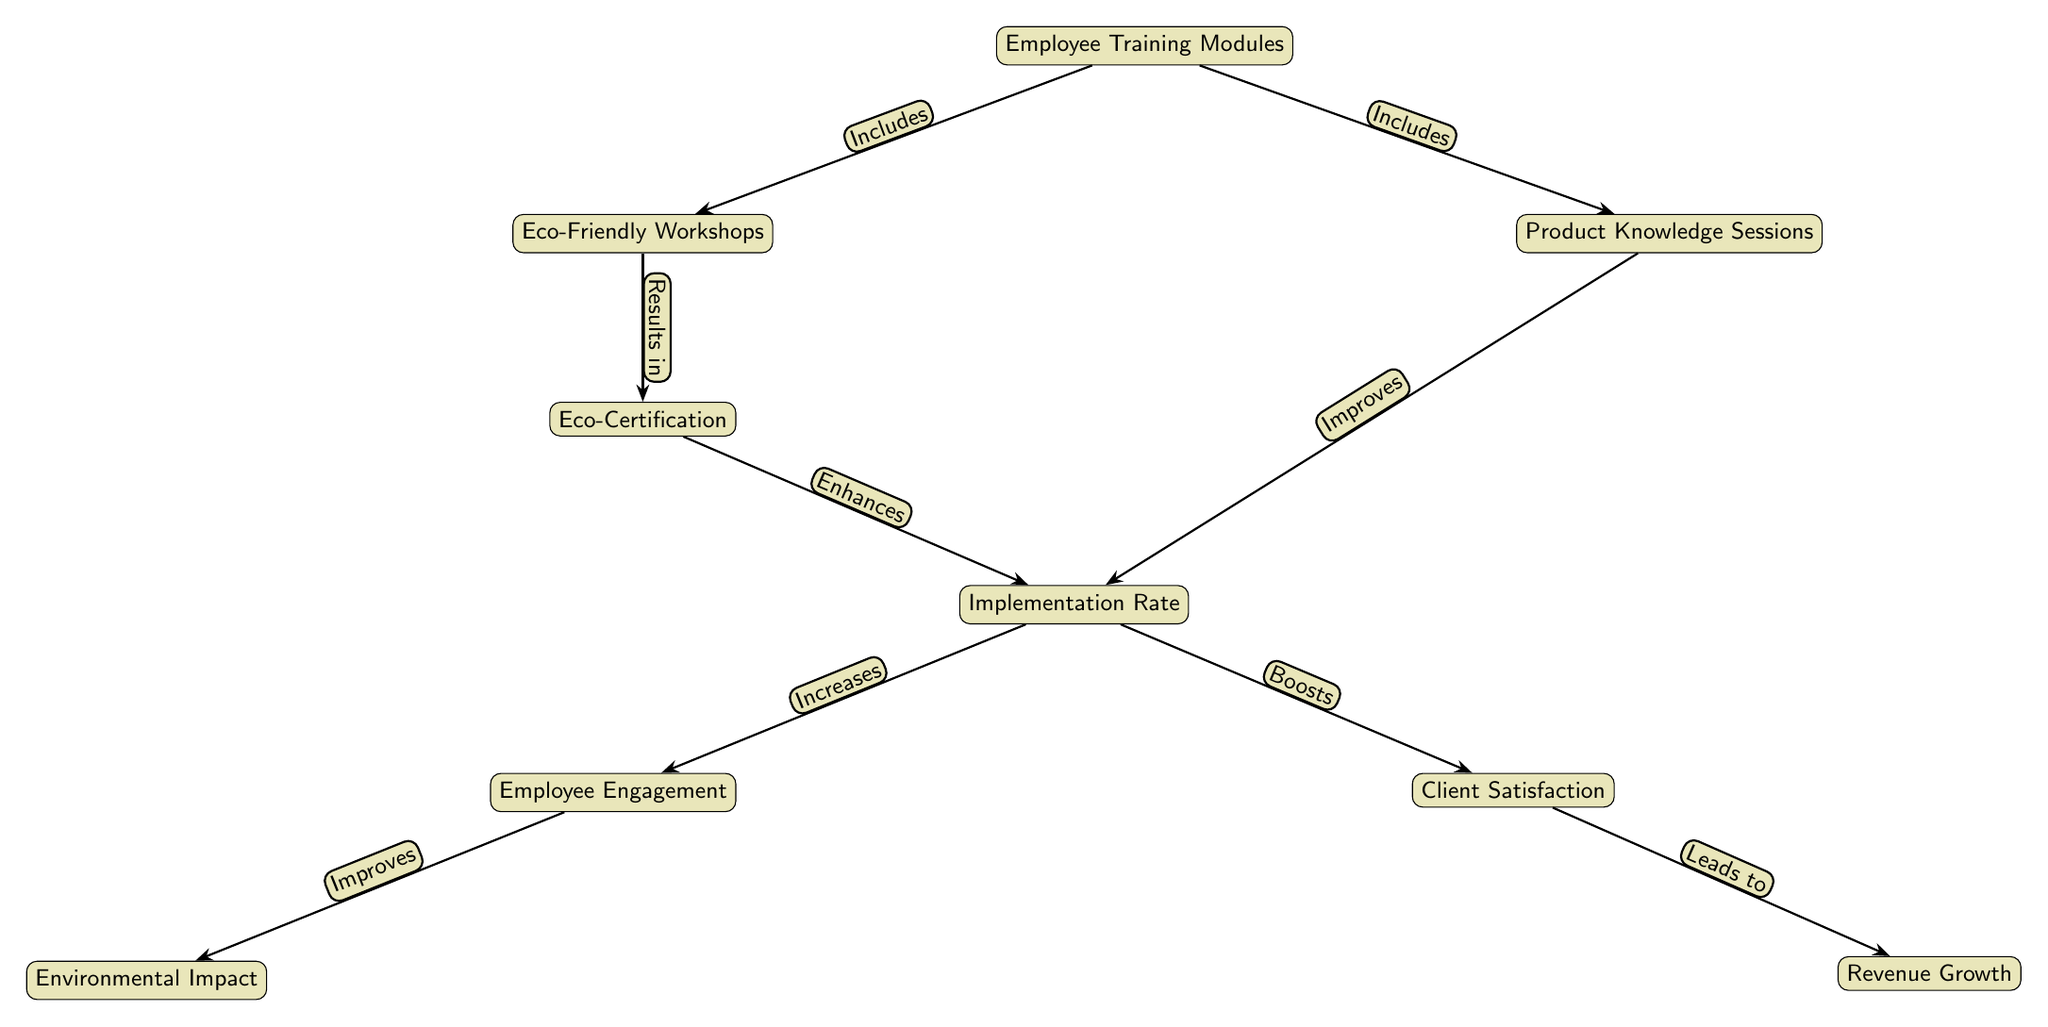What is the first node in the diagram? The first node is "Employee Training Modules." It is the starting point of the flow in the diagram, indicating the beginning of the training process.
Answer: Employee Training Modules How many main nodes are in the diagram? By counting the main nodes, we see there are eight distinct nodes representing different aspects of the training and outcomes related to eco-friendly practices.
Answer: Eight What is the relationship represented by the edge from "Workshops" to "Certification"? The edge indicates that the Eco-Friendly Workshops "Results in" Eco-Certification, meaning that attending the workshops leads to employees obtaining certification.
Answer: Results in What does "Implementation Rate" increase? According to the diagram, the Implementation Rate "Increases" Employee Engagement, signifying that a higher implementation rate contributes positively to employee involvement.
Answer: Employee Engagement What are the two outcomes influenced by "Implementation Rate"? The diagrams show that Implementation Rate influences both "Client Satisfaction" and "Employee Engagement," which are outcomes resulting from effective implementation of training.
Answer: Client Satisfaction and Employee Engagement If "Client Satisfaction" leads to "Revenue Growth," what influences "Client Satisfaction"? The diagram shows that "Client Satisfaction" is boosted by an increased "Implementation Rate," indicating that the effectiveness of implementation enhances client experiences, leading to greater satisfaction.
Answer: Implementation Rate Which node is at the furthest left position? The furthest left node in the diagram is "Eco-Friendly Workshops," which signifies a focus on training related to eco-conscious practices before progressing to certification and outcomes.
Answer: Eco-Friendly Workshops What does "Eco-Certification" enhance? "Eco-Certification" enhances the "Implementation Rate," indicating that obtaining this certification improves the actual implementation of eco-friendly practices in the salons.
Answer: Implementation Rate In what way does "Employee Engagement" influence outcomes? "Employee Engagement" improves "Environmental Impact," illustrating that higher engagement among employees leads to better results in terms of environmental practices in the salon.
Answer: Environmental Impact 